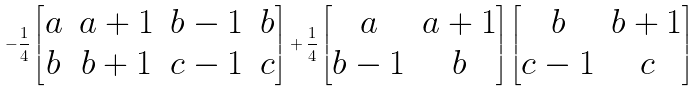<formula> <loc_0><loc_0><loc_500><loc_500>- \frac { 1 } { 4 } \begin{bmatrix} a & a + 1 & b - 1 & b \\ b & b + 1 & c - 1 & c \end{bmatrix} + \frac { 1 } { 4 } \begin{bmatrix} a & a + 1 \\ b - 1 & b \end{bmatrix} \begin{bmatrix} b & b + 1 \\ c - 1 & c \end{bmatrix}</formula> 